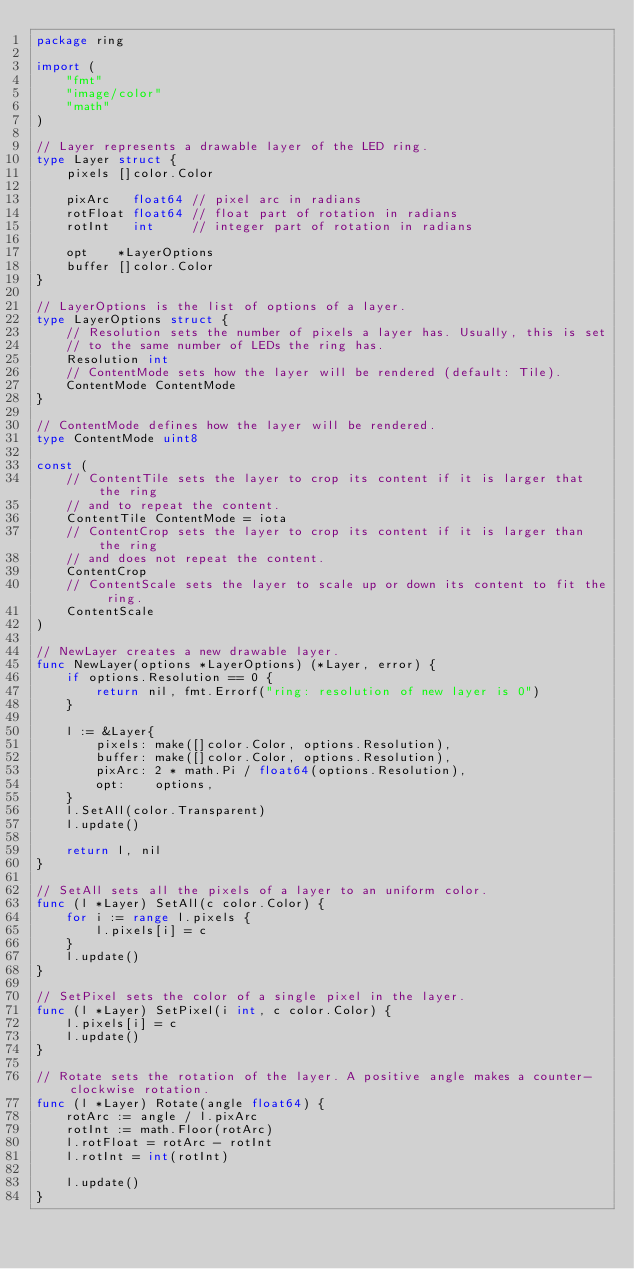Convert code to text. <code><loc_0><loc_0><loc_500><loc_500><_Go_>package ring

import (
	"fmt"
	"image/color"
	"math"
)

// Layer represents a drawable layer of the LED ring.
type Layer struct {
	pixels []color.Color

	pixArc   float64 // pixel arc in radians
	rotFloat float64 // float part of rotation in radians
	rotInt   int     // integer part of rotation in radians

	opt    *LayerOptions
	buffer []color.Color
}

// LayerOptions is the list of options of a layer.
type LayerOptions struct {
	// Resolution sets the number of pixels a layer has. Usually, this is set
	// to the same number of LEDs the ring has.
	Resolution int
	// ContentMode sets how the layer will be rendered (default: Tile).
	ContentMode ContentMode
}

// ContentMode defines how the layer will be rendered.
type ContentMode uint8

const (
	// ContentTile sets the layer to crop its content if it is larger that the ring
	// and to repeat the content.
	ContentTile ContentMode = iota
	// ContentCrop sets the layer to crop its content if it is larger than the ring
	// and does not repeat the content.
	ContentCrop
	// ContentScale sets the layer to scale up or down its content to fit the ring.
	ContentScale
)

// NewLayer creates a new drawable layer.
func NewLayer(options *LayerOptions) (*Layer, error) {
	if options.Resolution == 0 {
		return nil, fmt.Errorf("ring: resolution of new layer is 0")
	}

	l := &Layer{
		pixels: make([]color.Color, options.Resolution),
		buffer: make([]color.Color, options.Resolution),
		pixArc: 2 * math.Pi / float64(options.Resolution),
		opt:    options,
	}
	l.SetAll(color.Transparent)
	l.update()

	return l, nil
}

// SetAll sets all the pixels of a layer to an uniform color.
func (l *Layer) SetAll(c color.Color) {
	for i := range l.pixels {
		l.pixels[i] = c
	}
	l.update()
}

// SetPixel sets the color of a single pixel in the layer.
func (l *Layer) SetPixel(i int, c color.Color) {
	l.pixels[i] = c
	l.update()
}

// Rotate sets the rotation of the layer. A positive angle makes a counter-clockwise rotation.
func (l *Layer) Rotate(angle float64) {
	rotArc := angle / l.pixArc
	rotInt := math.Floor(rotArc)
	l.rotFloat = rotArc - rotInt
	l.rotInt = int(rotInt)

	l.update()
}
</code> 